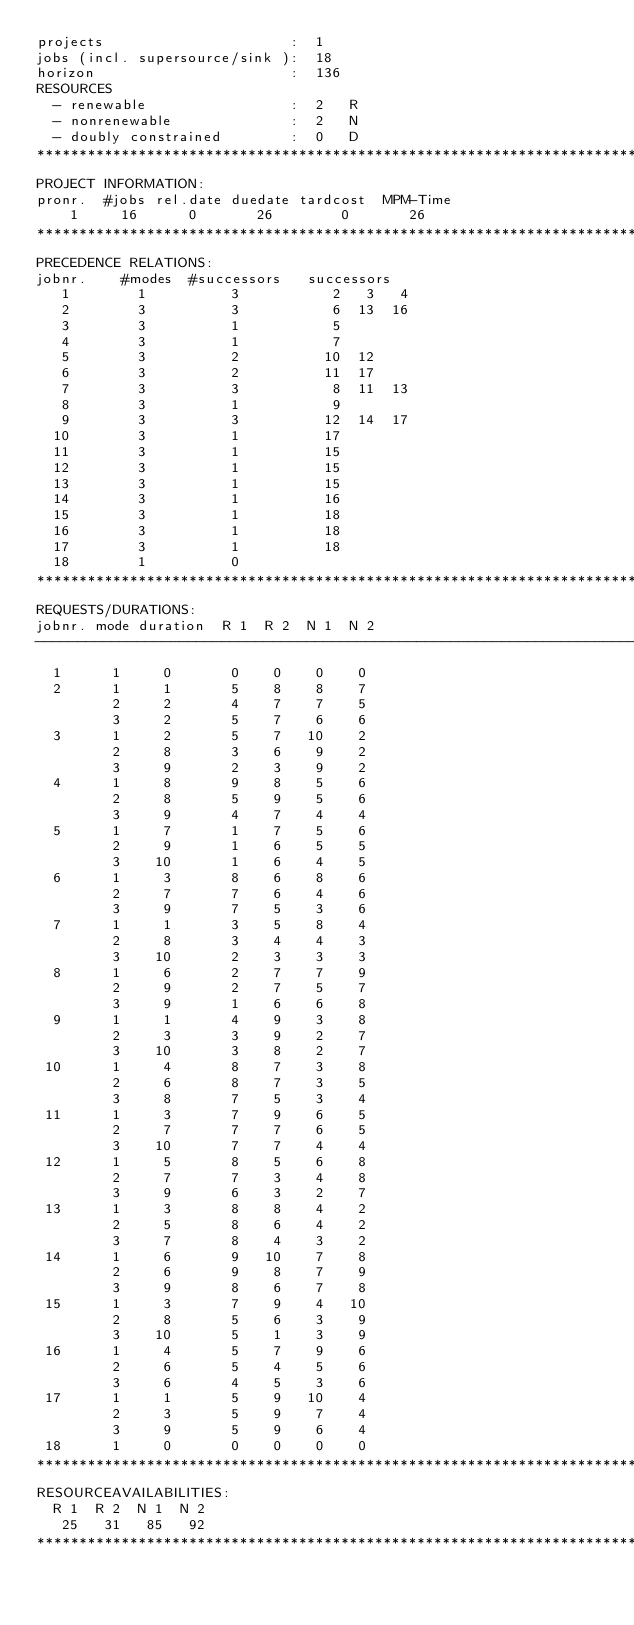Convert code to text. <code><loc_0><loc_0><loc_500><loc_500><_ObjectiveC_>projects                      :  1
jobs (incl. supersource/sink ):  18
horizon                       :  136
RESOURCES
  - renewable                 :  2   R
  - nonrenewable              :  2   N
  - doubly constrained        :  0   D
************************************************************************
PROJECT INFORMATION:
pronr.  #jobs rel.date duedate tardcost  MPM-Time
    1     16      0       26        0       26
************************************************************************
PRECEDENCE RELATIONS:
jobnr.    #modes  #successors   successors
   1        1          3           2   3   4
   2        3          3           6  13  16
   3        3          1           5
   4        3          1           7
   5        3          2          10  12
   6        3          2          11  17
   7        3          3           8  11  13
   8        3          1           9
   9        3          3          12  14  17
  10        3          1          17
  11        3          1          15
  12        3          1          15
  13        3          1          15
  14        3          1          16
  15        3          1          18
  16        3          1          18
  17        3          1          18
  18        1          0        
************************************************************************
REQUESTS/DURATIONS:
jobnr. mode duration  R 1  R 2  N 1  N 2
------------------------------------------------------------------------
  1      1     0       0    0    0    0
  2      1     1       5    8    8    7
         2     2       4    7    7    5
         3     2       5    7    6    6
  3      1     2       5    7   10    2
         2     8       3    6    9    2
         3     9       2    3    9    2
  4      1     8       9    8    5    6
         2     8       5    9    5    6
         3     9       4    7    4    4
  5      1     7       1    7    5    6
         2     9       1    6    5    5
         3    10       1    6    4    5
  6      1     3       8    6    8    6
         2     7       7    6    4    6
         3     9       7    5    3    6
  7      1     1       3    5    8    4
         2     8       3    4    4    3
         3    10       2    3    3    3
  8      1     6       2    7    7    9
         2     9       2    7    5    7
         3     9       1    6    6    8
  9      1     1       4    9    3    8
         2     3       3    9    2    7
         3    10       3    8    2    7
 10      1     4       8    7    3    8
         2     6       8    7    3    5
         3     8       7    5    3    4
 11      1     3       7    9    6    5
         2     7       7    7    6    5
         3    10       7    7    4    4
 12      1     5       8    5    6    8
         2     7       7    3    4    8
         3     9       6    3    2    7
 13      1     3       8    8    4    2
         2     5       8    6    4    2
         3     7       8    4    3    2
 14      1     6       9   10    7    8
         2     6       9    8    7    9
         3     9       8    6    7    8
 15      1     3       7    9    4   10
         2     8       5    6    3    9
         3    10       5    1    3    9
 16      1     4       5    7    9    6
         2     6       5    4    5    6
         3     6       4    5    3    6
 17      1     1       5    9   10    4
         2     3       5    9    7    4
         3     9       5    9    6    4
 18      1     0       0    0    0    0
************************************************************************
RESOURCEAVAILABILITIES:
  R 1  R 2  N 1  N 2
   25   31   85   92
************************************************************************
</code> 